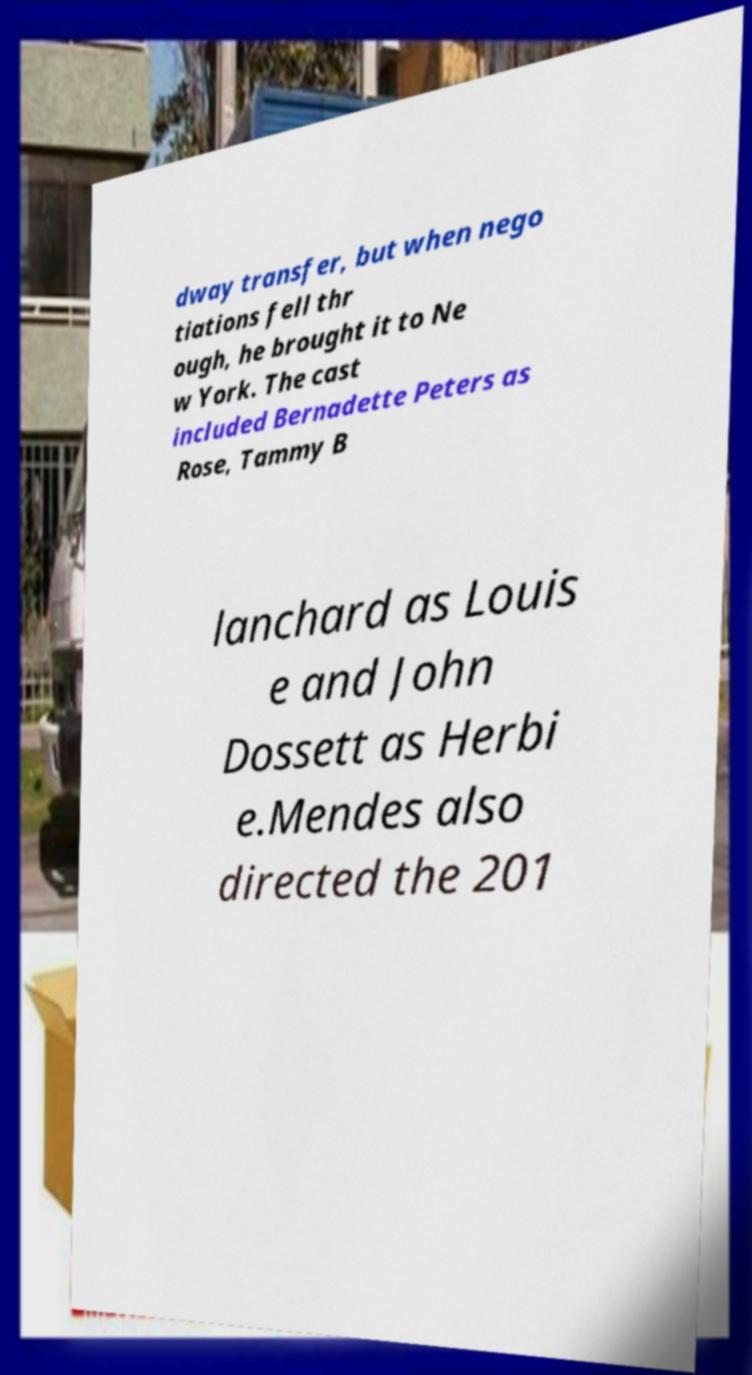There's text embedded in this image that I need extracted. Can you transcribe it verbatim? dway transfer, but when nego tiations fell thr ough, he brought it to Ne w York. The cast included Bernadette Peters as Rose, Tammy B lanchard as Louis e and John Dossett as Herbi e.Mendes also directed the 201 